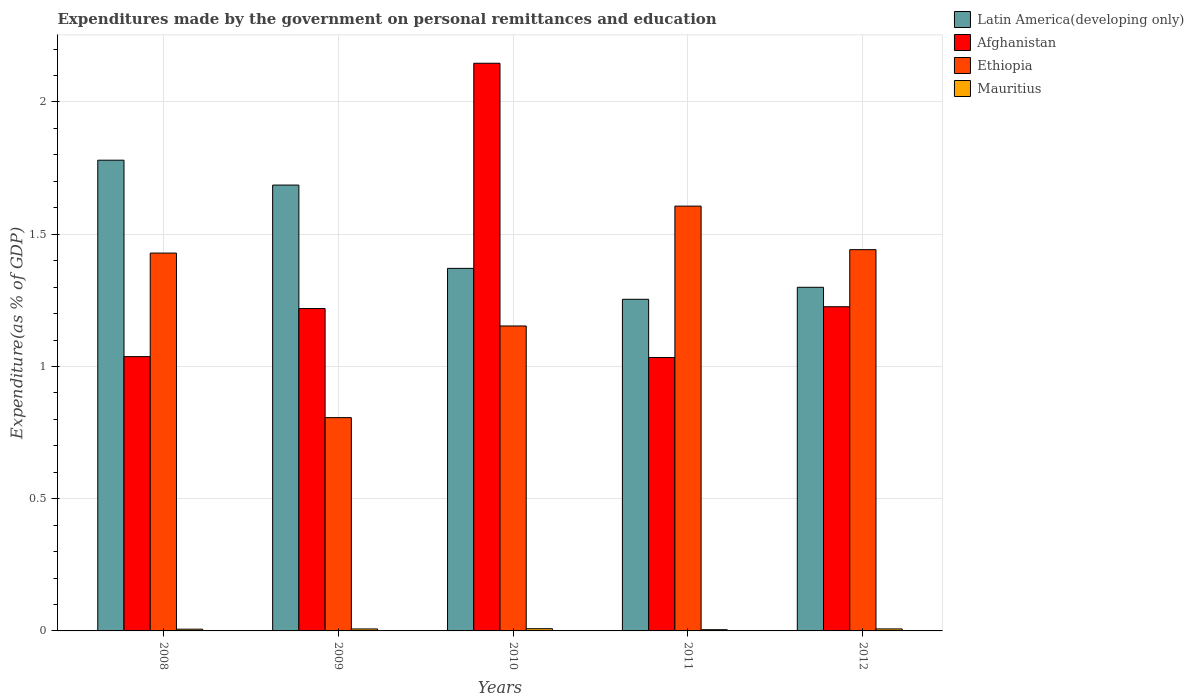What is the expenditures made by the government on personal remittances and education in Mauritius in 2009?
Provide a succinct answer. 0.01. Across all years, what is the maximum expenditures made by the government on personal remittances and education in Latin America(developing only)?
Your answer should be very brief. 1.78. Across all years, what is the minimum expenditures made by the government on personal remittances and education in Mauritius?
Offer a terse response. 0. In which year was the expenditures made by the government on personal remittances and education in Latin America(developing only) minimum?
Offer a terse response. 2011. What is the total expenditures made by the government on personal remittances and education in Latin America(developing only) in the graph?
Provide a short and direct response. 7.39. What is the difference between the expenditures made by the government on personal remittances and education in Ethiopia in 2009 and that in 2012?
Make the answer very short. -0.64. What is the difference between the expenditures made by the government on personal remittances and education in Mauritius in 2011 and the expenditures made by the government on personal remittances and education in Latin America(developing only) in 2010?
Make the answer very short. -1.37. What is the average expenditures made by the government on personal remittances and education in Ethiopia per year?
Provide a succinct answer. 1.29. In the year 2012, what is the difference between the expenditures made by the government on personal remittances and education in Ethiopia and expenditures made by the government on personal remittances and education in Latin America(developing only)?
Make the answer very short. 0.14. What is the ratio of the expenditures made by the government on personal remittances and education in Latin America(developing only) in 2008 to that in 2012?
Your answer should be compact. 1.37. Is the difference between the expenditures made by the government on personal remittances and education in Ethiopia in 2010 and 2012 greater than the difference between the expenditures made by the government on personal remittances and education in Latin America(developing only) in 2010 and 2012?
Your response must be concise. No. What is the difference between the highest and the second highest expenditures made by the government on personal remittances and education in Mauritius?
Make the answer very short. 0. What is the difference between the highest and the lowest expenditures made by the government on personal remittances and education in Latin America(developing only)?
Ensure brevity in your answer.  0.53. In how many years, is the expenditures made by the government on personal remittances and education in Afghanistan greater than the average expenditures made by the government on personal remittances and education in Afghanistan taken over all years?
Provide a short and direct response. 1. Is the sum of the expenditures made by the government on personal remittances and education in Afghanistan in 2010 and 2012 greater than the maximum expenditures made by the government on personal remittances and education in Latin America(developing only) across all years?
Give a very brief answer. Yes. What does the 3rd bar from the left in 2011 represents?
Ensure brevity in your answer.  Ethiopia. What does the 1st bar from the right in 2012 represents?
Offer a terse response. Mauritius. Is it the case that in every year, the sum of the expenditures made by the government on personal remittances and education in Latin America(developing only) and expenditures made by the government on personal remittances and education in Mauritius is greater than the expenditures made by the government on personal remittances and education in Ethiopia?
Give a very brief answer. No. Does the graph contain grids?
Provide a short and direct response. Yes. Where does the legend appear in the graph?
Offer a terse response. Top right. What is the title of the graph?
Provide a succinct answer. Expenditures made by the government on personal remittances and education. Does "Japan" appear as one of the legend labels in the graph?
Your answer should be compact. No. What is the label or title of the X-axis?
Your response must be concise. Years. What is the label or title of the Y-axis?
Keep it short and to the point. Expenditure(as % of GDP). What is the Expenditure(as % of GDP) of Latin America(developing only) in 2008?
Give a very brief answer. 1.78. What is the Expenditure(as % of GDP) of Afghanistan in 2008?
Offer a very short reply. 1.04. What is the Expenditure(as % of GDP) in Ethiopia in 2008?
Provide a short and direct response. 1.43. What is the Expenditure(as % of GDP) in Mauritius in 2008?
Make the answer very short. 0.01. What is the Expenditure(as % of GDP) in Latin America(developing only) in 2009?
Offer a very short reply. 1.69. What is the Expenditure(as % of GDP) of Afghanistan in 2009?
Keep it short and to the point. 1.22. What is the Expenditure(as % of GDP) of Ethiopia in 2009?
Offer a terse response. 0.81. What is the Expenditure(as % of GDP) in Mauritius in 2009?
Offer a terse response. 0.01. What is the Expenditure(as % of GDP) of Latin America(developing only) in 2010?
Ensure brevity in your answer.  1.37. What is the Expenditure(as % of GDP) of Afghanistan in 2010?
Offer a terse response. 2.15. What is the Expenditure(as % of GDP) in Ethiopia in 2010?
Your response must be concise. 1.15. What is the Expenditure(as % of GDP) of Mauritius in 2010?
Your response must be concise. 0.01. What is the Expenditure(as % of GDP) in Latin America(developing only) in 2011?
Offer a terse response. 1.25. What is the Expenditure(as % of GDP) in Afghanistan in 2011?
Offer a terse response. 1.03. What is the Expenditure(as % of GDP) of Ethiopia in 2011?
Give a very brief answer. 1.61. What is the Expenditure(as % of GDP) of Mauritius in 2011?
Ensure brevity in your answer.  0. What is the Expenditure(as % of GDP) in Latin America(developing only) in 2012?
Offer a terse response. 1.3. What is the Expenditure(as % of GDP) of Afghanistan in 2012?
Your response must be concise. 1.23. What is the Expenditure(as % of GDP) in Ethiopia in 2012?
Your response must be concise. 1.44. What is the Expenditure(as % of GDP) of Mauritius in 2012?
Offer a very short reply. 0.01. Across all years, what is the maximum Expenditure(as % of GDP) of Latin America(developing only)?
Provide a succinct answer. 1.78. Across all years, what is the maximum Expenditure(as % of GDP) of Afghanistan?
Keep it short and to the point. 2.15. Across all years, what is the maximum Expenditure(as % of GDP) of Ethiopia?
Offer a very short reply. 1.61. Across all years, what is the maximum Expenditure(as % of GDP) of Mauritius?
Provide a succinct answer. 0.01. Across all years, what is the minimum Expenditure(as % of GDP) in Latin America(developing only)?
Provide a succinct answer. 1.25. Across all years, what is the minimum Expenditure(as % of GDP) in Afghanistan?
Give a very brief answer. 1.03. Across all years, what is the minimum Expenditure(as % of GDP) of Ethiopia?
Provide a short and direct response. 0.81. Across all years, what is the minimum Expenditure(as % of GDP) in Mauritius?
Ensure brevity in your answer.  0. What is the total Expenditure(as % of GDP) in Latin America(developing only) in the graph?
Your answer should be very brief. 7.39. What is the total Expenditure(as % of GDP) of Afghanistan in the graph?
Give a very brief answer. 6.66. What is the total Expenditure(as % of GDP) in Ethiopia in the graph?
Your response must be concise. 6.44. What is the total Expenditure(as % of GDP) of Mauritius in the graph?
Your answer should be very brief. 0.03. What is the difference between the Expenditure(as % of GDP) of Latin America(developing only) in 2008 and that in 2009?
Make the answer very short. 0.09. What is the difference between the Expenditure(as % of GDP) in Afghanistan in 2008 and that in 2009?
Your response must be concise. -0.18. What is the difference between the Expenditure(as % of GDP) of Ethiopia in 2008 and that in 2009?
Offer a very short reply. 0.62. What is the difference between the Expenditure(as % of GDP) of Mauritius in 2008 and that in 2009?
Provide a short and direct response. -0. What is the difference between the Expenditure(as % of GDP) of Latin America(developing only) in 2008 and that in 2010?
Offer a very short reply. 0.41. What is the difference between the Expenditure(as % of GDP) of Afghanistan in 2008 and that in 2010?
Provide a succinct answer. -1.11. What is the difference between the Expenditure(as % of GDP) in Ethiopia in 2008 and that in 2010?
Your answer should be very brief. 0.28. What is the difference between the Expenditure(as % of GDP) in Mauritius in 2008 and that in 2010?
Your answer should be compact. -0. What is the difference between the Expenditure(as % of GDP) in Latin America(developing only) in 2008 and that in 2011?
Make the answer very short. 0.53. What is the difference between the Expenditure(as % of GDP) of Afghanistan in 2008 and that in 2011?
Provide a short and direct response. 0. What is the difference between the Expenditure(as % of GDP) in Ethiopia in 2008 and that in 2011?
Keep it short and to the point. -0.18. What is the difference between the Expenditure(as % of GDP) of Mauritius in 2008 and that in 2011?
Provide a short and direct response. 0. What is the difference between the Expenditure(as % of GDP) in Latin America(developing only) in 2008 and that in 2012?
Offer a terse response. 0.48. What is the difference between the Expenditure(as % of GDP) in Afghanistan in 2008 and that in 2012?
Your answer should be very brief. -0.19. What is the difference between the Expenditure(as % of GDP) of Ethiopia in 2008 and that in 2012?
Provide a short and direct response. -0.01. What is the difference between the Expenditure(as % of GDP) in Mauritius in 2008 and that in 2012?
Ensure brevity in your answer.  -0. What is the difference between the Expenditure(as % of GDP) in Latin America(developing only) in 2009 and that in 2010?
Offer a terse response. 0.32. What is the difference between the Expenditure(as % of GDP) of Afghanistan in 2009 and that in 2010?
Provide a succinct answer. -0.93. What is the difference between the Expenditure(as % of GDP) of Ethiopia in 2009 and that in 2010?
Ensure brevity in your answer.  -0.35. What is the difference between the Expenditure(as % of GDP) of Mauritius in 2009 and that in 2010?
Keep it short and to the point. -0. What is the difference between the Expenditure(as % of GDP) of Latin America(developing only) in 2009 and that in 2011?
Ensure brevity in your answer.  0.43. What is the difference between the Expenditure(as % of GDP) of Afghanistan in 2009 and that in 2011?
Keep it short and to the point. 0.19. What is the difference between the Expenditure(as % of GDP) in Ethiopia in 2009 and that in 2011?
Ensure brevity in your answer.  -0.8. What is the difference between the Expenditure(as % of GDP) in Mauritius in 2009 and that in 2011?
Your answer should be compact. 0. What is the difference between the Expenditure(as % of GDP) of Latin America(developing only) in 2009 and that in 2012?
Provide a succinct answer. 0.39. What is the difference between the Expenditure(as % of GDP) in Afghanistan in 2009 and that in 2012?
Ensure brevity in your answer.  -0.01. What is the difference between the Expenditure(as % of GDP) in Ethiopia in 2009 and that in 2012?
Keep it short and to the point. -0.64. What is the difference between the Expenditure(as % of GDP) of Mauritius in 2009 and that in 2012?
Ensure brevity in your answer.  -0. What is the difference between the Expenditure(as % of GDP) in Latin America(developing only) in 2010 and that in 2011?
Offer a terse response. 0.12. What is the difference between the Expenditure(as % of GDP) in Afghanistan in 2010 and that in 2011?
Make the answer very short. 1.11. What is the difference between the Expenditure(as % of GDP) in Ethiopia in 2010 and that in 2011?
Your response must be concise. -0.45. What is the difference between the Expenditure(as % of GDP) of Mauritius in 2010 and that in 2011?
Provide a short and direct response. 0. What is the difference between the Expenditure(as % of GDP) in Latin America(developing only) in 2010 and that in 2012?
Your answer should be very brief. 0.07. What is the difference between the Expenditure(as % of GDP) of Afghanistan in 2010 and that in 2012?
Provide a succinct answer. 0.92. What is the difference between the Expenditure(as % of GDP) of Ethiopia in 2010 and that in 2012?
Make the answer very short. -0.29. What is the difference between the Expenditure(as % of GDP) in Mauritius in 2010 and that in 2012?
Provide a short and direct response. 0. What is the difference between the Expenditure(as % of GDP) of Latin America(developing only) in 2011 and that in 2012?
Ensure brevity in your answer.  -0.05. What is the difference between the Expenditure(as % of GDP) in Afghanistan in 2011 and that in 2012?
Keep it short and to the point. -0.19. What is the difference between the Expenditure(as % of GDP) of Ethiopia in 2011 and that in 2012?
Keep it short and to the point. 0.16. What is the difference between the Expenditure(as % of GDP) in Mauritius in 2011 and that in 2012?
Provide a short and direct response. -0. What is the difference between the Expenditure(as % of GDP) in Latin America(developing only) in 2008 and the Expenditure(as % of GDP) in Afghanistan in 2009?
Make the answer very short. 0.56. What is the difference between the Expenditure(as % of GDP) in Latin America(developing only) in 2008 and the Expenditure(as % of GDP) in Ethiopia in 2009?
Offer a very short reply. 0.97. What is the difference between the Expenditure(as % of GDP) in Latin America(developing only) in 2008 and the Expenditure(as % of GDP) in Mauritius in 2009?
Your response must be concise. 1.77. What is the difference between the Expenditure(as % of GDP) of Afghanistan in 2008 and the Expenditure(as % of GDP) of Ethiopia in 2009?
Give a very brief answer. 0.23. What is the difference between the Expenditure(as % of GDP) in Afghanistan in 2008 and the Expenditure(as % of GDP) in Mauritius in 2009?
Ensure brevity in your answer.  1.03. What is the difference between the Expenditure(as % of GDP) in Ethiopia in 2008 and the Expenditure(as % of GDP) in Mauritius in 2009?
Your answer should be compact. 1.42. What is the difference between the Expenditure(as % of GDP) in Latin America(developing only) in 2008 and the Expenditure(as % of GDP) in Afghanistan in 2010?
Offer a very short reply. -0.37. What is the difference between the Expenditure(as % of GDP) in Latin America(developing only) in 2008 and the Expenditure(as % of GDP) in Ethiopia in 2010?
Offer a very short reply. 0.63. What is the difference between the Expenditure(as % of GDP) of Latin America(developing only) in 2008 and the Expenditure(as % of GDP) of Mauritius in 2010?
Your response must be concise. 1.77. What is the difference between the Expenditure(as % of GDP) of Afghanistan in 2008 and the Expenditure(as % of GDP) of Ethiopia in 2010?
Your response must be concise. -0.12. What is the difference between the Expenditure(as % of GDP) in Afghanistan in 2008 and the Expenditure(as % of GDP) in Mauritius in 2010?
Give a very brief answer. 1.03. What is the difference between the Expenditure(as % of GDP) in Ethiopia in 2008 and the Expenditure(as % of GDP) in Mauritius in 2010?
Offer a terse response. 1.42. What is the difference between the Expenditure(as % of GDP) in Latin America(developing only) in 2008 and the Expenditure(as % of GDP) in Afghanistan in 2011?
Offer a very short reply. 0.75. What is the difference between the Expenditure(as % of GDP) in Latin America(developing only) in 2008 and the Expenditure(as % of GDP) in Ethiopia in 2011?
Offer a terse response. 0.17. What is the difference between the Expenditure(as % of GDP) in Latin America(developing only) in 2008 and the Expenditure(as % of GDP) in Mauritius in 2011?
Your answer should be compact. 1.78. What is the difference between the Expenditure(as % of GDP) of Afghanistan in 2008 and the Expenditure(as % of GDP) of Ethiopia in 2011?
Keep it short and to the point. -0.57. What is the difference between the Expenditure(as % of GDP) in Afghanistan in 2008 and the Expenditure(as % of GDP) in Mauritius in 2011?
Offer a terse response. 1.03. What is the difference between the Expenditure(as % of GDP) in Ethiopia in 2008 and the Expenditure(as % of GDP) in Mauritius in 2011?
Make the answer very short. 1.42. What is the difference between the Expenditure(as % of GDP) in Latin America(developing only) in 2008 and the Expenditure(as % of GDP) in Afghanistan in 2012?
Your response must be concise. 0.55. What is the difference between the Expenditure(as % of GDP) of Latin America(developing only) in 2008 and the Expenditure(as % of GDP) of Ethiopia in 2012?
Give a very brief answer. 0.34. What is the difference between the Expenditure(as % of GDP) in Latin America(developing only) in 2008 and the Expenditure(as % of GDP) in Mauritius in 2012?
Ensure brevity in your answer.  1.77. What is the difference between the Expenditure(as % of GDP) of Afghanistan in 2008 and the Expenditure(as % of GDP) of Ethiopia in 2012?
Offer a terse response. -0.4. What is the difference between the Expenditure(as % of GDP) of Afghanistan in 2008 and the Expenditure(as % of GDP) of Mauritius in 2012?
Ensure brevity in your answer.  1.03. What is the difference between the Expenditure(as % of GDP) in Ethiopia in 2008 and the Expenditure(as % of GDP) in Mauritius in 2012?
Ensure brevity in your answer.  1.42. What is the difference between the Expenditure(as % of GDP) of Latin America(developing only) in 2009 and the Expenditure(as % of GDP) of Afghanistan in 2010?
Your response must be concise. -0.46. What is the difference between the Expenditure(as % of GDP) in Latin America(developing only) in 2009 and the Expenditure(as % of GDP) in Ethiopia in 2010?
Provide a succinct answer. 0.53. What is the difference between the Expenditure(as % of GDP) of Latin America(developing only) in 2009 and the Expenditure(as % of GDP) of Mauritius in 2010?
Your response must be concise. 1.68. What is the difference between the Expenditure(as % of GDP) in Afghanistan in 2009 and the Expenditure(as % of GDP) in Ethiopia in 2010?
Provide a succinct answer. 0.07. What is the difference between the Expenditure(as % of GDP) of Afghanistan in 2009 and the Expenditure(as % of GDP) of Mauritius in 2010?
Make the answer very short. 1.21. What is the difference between the Expenditure(as % of GDP) in Ethiopia in 2009 and the Expenditure(as % of GDP) in Mauritius in 2010?
Provide a succinct answer. 0.8. What is the difference between the Expenditure(as % of GDP) of Latin America(developing only) in 2009 and the Expenditure(as % of GDP) of Afghanistan in 2011?
Offer a terse response. 0.65. What is the difference between the Expenditure(as % of GDP) in Latin America(developing only) in 2009 and the Expenditure(as % of GDP) in Ethiopia in 2011?
Your response must be concise. 0.08. What is the difference between the Expenditure(as % of GDP) in Latin America(developing only) in 2009 and the Expenditure(as % of GDP) in Mauritius in 2011?
Provide a short and direct response. 1.68. What is the difference between the Expenditure(as % of GDP) of Afghanistan in 2009 and the Expenditure(as % of GDP) of Ethiopia in 2011?
Keep it short and to the point. -0.39. What is the difference between the Expenditure(as % of GDP) of Afghanistan in 2009 and the Expenditure(as % of GDP) of Mauritius in 2011?
Your answer should be compact. 1.21. What is the difference between the Expenditure(as % of GDP) in Ethiopia in 2009 and the Expenditure(as % of GDP) in Mauritius in 2011?
Make the answer very short. 0.8. What is the difference between the Expenditure(as % of GDP) of Latin America(developing only) in 2009 and the Expenditure(as % of GDP) of Afghanistan in 2012?
Your response must be concise. 0.46. What is the difference between the Expenditure(as % of GDP) in Latin America(developing only) in 2009 and the Expenditure(as % of GDP) in Ethiopia in 2012?
Your response must be concise. 0.24. What is the difference between the Expenditure(as % of GDP) in Latin America(developing only) in 2009 and the Expenditure(as % of GDP) in Mauritius in 2012?
Make the answer very short. 1.68. What is the difference between the Expenditure(as % of GDP) in Afghanistan in 2009 and the Expenditure(as % of GDP) in Ethiopia in 2012?
Keep it short and to the point. -0.22. What is the difference between the Expenditure(as % of GDP) in Afghanistan in 2009 and the Expenditure(as % of GDP) in Mauritius in 2012?
Give a very brief answer. 1.21. What is the difference between the Expenditure(as % of GDP) of Ethiopia in 2009 and the Expenditure(as % of GDP) of Mauritius in 2012?
Make the answer very short. 0.8. What is the difference between the Expenditure(as % of GDP) of Latin America(developing only) in 2010 and the Expenditure(as % of GDP) of Afghanistan in 2011?
Make the answer very short. 0.34. What is the difference between the Expenditure(as % of GDP) of Latin America(developing only) in 2010 and the Expenditure(as % of GDP) of Ethiopia in 2011?
Your answer should be very brief. -0.24. What is the difference between the Expenditure(as % of GDP) of Latin America(developing only) in 2010 and the Expenditure(as % of GDP) of Mauritius in 2011?
Offer a terse response. 1.37. What is the difference between the Expenditure(as % of GDP) in Afghanistan in 2010 and the Expenditure(as % of GDP) in Ethiopia in 2011?
Offer a terse response. 0.54. What is the difference between the Expenditure(as % of GDP) in Afghanistan in 2010 and the Expenditure(as % of GDP) in Mauritius in 2011?
Make the answer very short. 2.14. What is the difference between the Expenditure(as % of GDP) of Ethiopia in 2010 and the Expenditure(as % of GDP) of Mauritius in 2011?
Provide a succinct answer. 1.15. What is the difference between the Expenditure(as % of GDP) in Latin America(developing only) in 2010 and the Expenditure(as % of GDP) in Afghanistan in 2012?
Provide a short and direct response. 0.14. What is the difference between the Expenditure(as % of GDP) in Latin America(developing only) in 2010 and the Expenditure(as % of GDP) in Ethiopia in 2012?
Give a very brief answer. -0.07. What is the difference between the Expenditure(as % of GDP) in Latin America(developing only) in 2010 and the Expenditure(as % of GDP) in Mauritius in 2012?
Your answer should be compact. 1.36. What is the difference between the Expenditure(as % of GDP) of Afghanistan in 2010 and the Expenditure(as % of GDP) of Ethiopia in 2012?
Ensure brevity in your answer.  0.7. What is the difference between the Expenditure(as % of GDP) in Afghanistan in 2010 and the Expenditure(as % of GDP) in Mauritius in 2012?
Offer a terse response. 2.14. What is the difference between the Expenditure(as % of GDP) in Ethiopia in 2010 and the Expenditure(as % of GDP) in Mauritius in 2012?
Ensure brevity in your answer.  1.15. What is the difference between the Expenditure(as % of GDP) in Latin America(developing only) in 2011 and the Expenditure(as % of GDP) in Afghanistan in 2012?
Make the answer very short. 0.03. What is the difference between the Expenditure(as % of GDP) in Latin America(developing only) in 2011 and the Expenditure(as % of GDP) in Ethiopia in 2012?
Your response must be concise. -0.19. What is the difference between the Expenditure(as % of GDP) of Latin America(developing only) in 2011 and the Expenditure(as % of GDP) of Mauritius in 2012?
Your response must be concise. 1.25. What is the difference between the Expenditure(as % of GDP) of Afghanistan in 2011 and the Expenditure(as % of GDP) of Ethiopia in 2012?
Your answer should be very brief. -0.41. What is the difference between the Expenditure(as % of GDP) of Afghanistan in 2011 and the Expenditure(as % of GDP) of Mauritius in 2012?
Keep it short and to the point. 1.03. What is the difference between the Expenditure(as % of GDP) of Ethiopia in 2011 and the Expenditure(as % of GDP) of Mauritius in 2012?
Offer a terse response. 1.6. What is the average Expenditure(as % of GDP) in Latin America(developing only) per year?
Make the answer very short. 1.48. What is the average Expenditure(as % of GDP) in Afghanistan per year?
Provide a short and direct response. 1.33. What is the average Expenditure(as % of GDP) in Ethiopia per year?
Offer a very short reply. 1.29. What is the average Expenditure(as % of GDP) of Mauritius per year?
Keep it short and to the point. 0.01. In the year 2008, what is the difference between the Expenditure(as % of GDP) of Latin America(developing only) and Expenditure(as % of GDP) of Afghanistan?
Keep it short and to the point. 0.74. In the year 2008, what is the difference between the Expenditure(as % of GDP) in Latin America(developing only) and Expenditure(as % of GDP) in Ethiopia?
Ensure brevity in your answer.  0.35. In the year 2008, what is the difference between the Expenditure(as % of GDP) of Latin America(developing only) and Expenditure(as % of GDP) of Mauritius?
Make the answer very short. 1.77. In the year 2008, what is the difference between the Expenditure(as % of GDP) in Afghanistan and Expenditure(as % of GDP) in Ethiopia?
Ensure brevity in your answer.  -0.39. In the year 2008, what is the difference between the Expenditure(as % of GDP) of Afghanistan and Expenditure(as % of GDP) of Mauritius?
Give a very brief answer. 1.03. In the year 2008, what is the difference between the Expenditure(as % of GDP) in Ethiopia and Expenditure(as % of GDP) in Mauritius?
Your answer should be compact. 1.42. In the year 2009, what is the difference between the Expenditure(as % of GDP) of Latin America(developing only) and Expenditure(as % of GDP) of Afghanistan?
Your answer should be very brief. 0.47. In the year 2009, what is the difference between the Expenditure(as % of GDP) in Latin America(developing only) and Expenditure(as % of GDP) in Ethiopia?
Give a very brief answer. 0.88. In the year 2009, what is the difference between the Expenditure(as % of GDP) of Latin America(developing only) and Expenditure(as % of GDP) of Mauritius?
Your answer should be compact. 1.68. In the year 2009, what is the difference between the Expenditure(as % of GDP) in Afghanistan and Expenditure(as % of GDP) in Ethiopia?
Provide a succinct answer. 0.41. In the year 2009, what is the difference between the Expenditure(as % of GDP) of Afghanistan and Expenditure(as % of GDP) of Mauritius?
Ensure brevity in your answer.  1.21. In the year 2009, what is the difference between the Expenditure(as % of GDP) of Ethiopia and Expenditure(as % of GDP) of Mauritius?
Provide a short and direct response. 0.8. In the year 2010, what is the difference between the Expenditure(as % of GDP) in Latin America(developing only) and Expenditure(as % of GDP) in Afghanistan?
Your answer should be very brief. -0.78. In the year 2010, what is the difference between the Expenditure(as % of GDP) of Latin America(developing only) and Expenditure(as % of GDP) of Ethiopia?
Keep it short and to the point. 0.22. In the year 2010, what is the difference between the Expenditure(as % of GDP) in Latin America(developing only) and Expenditure(as % of GDP) in Mauritius?
Offer a terse response. 1.36. In the year 2010, what is the difference between the Expenditure(as % of GDP) in Afghanistan and Expenditure(as % of GDP) in Ethiopia?
Your response must be concise. 0.99. In the year 2010, what is the difference between the Expenditure(as % of GDP) of Afghanistan and Expenditure(as % of GDP) of Mauritius?
Ensure brevity in your answer.  2.14. In the year 2010, what is the difference between the Expenditure(as % of GDP) of Ethiopia and Expenditure(as % of GDP) of Mauritius?
Keep it short and to the point. 1.14. In the year 2011, what is the difference between the Expenditure(as % of GDP) of Latin America(developing only) and Expenditure(as % of GDP) of Afghanistan?
Provide a succinct answer. 0.22. In the year 2011, what is the difference between the Expenditure(as % of GDP) of Latin America(developing only) and Expenditure(as % of GDP) of Ethiopia?
Offer a very short reply. -0.35. In the year 2011, what is the difference between the Expenditure(as % of GDP) of Latin America(developing only) and Expenditure(as % of GDP) of Mauritius?
Provide a succinct answer. 1.25. In the year 2011, what is the difference between the Expenditure(as % of GDP) in Afghanistan and Expenditure(as % of GDP) in Ethiopia?
Your response must be concise. -0.57. In the year 2011, what is the difference between the Expenditure(as % of GDP) of Afghanistan and Expenditure(as % of GDP) of Mauritius?
Provide a short and direct response. 1.03. In the year 2011, what is the difference between the Expenditure(as % of GDP) of Ethiopia and Expenditure(as % of GDP) of Mauritius?
Ensure brevity in your answer.  1.6. In the year 2012, what is the difference between the Expenditure(as % of GDP) in Latin America(developing only) and Expenditure(as % of GDP) in Afghanistan?
Provide a succinct answer. 0.07. In the year 2012, what is the difference between the Expenditure(as % of GDP) in Latin America(developing only) and Expenditure(as % of GDP) in Ethiopia?
Your response must be concise. -0.14. In the year 2012, what is the difference between the Expenditure(as % of GDP) in Latin America(developing only) and Expenditure(as % of GDP) in Mauritius?
Provide a short and direct response. 1.29. In the year 2012, what is the difference between the Expenditure(as % of GDP) in Afghanistan and Expenditure(as % of GDP) in Ethiopia?
Ensure brevity in your answer.  -0.22. In the year 2012, what is the difference between the Expenditure(as % of GDP) of Afghanistan and Expenditure(as % of GDP) of Mauritius?
Make the answer very short. 1.22. In the year 2012, what is the difference between the Expenditure(as % of GDP) of Ethiopia and Expenditure(as % of GDP) of Mauritius?
Give a very brief answer. 1.43. What is the ratio of the Expenditure(as % of GDP) in Latin America(developing only) in 2008 to that in 2009?
Provide a short and direct response. 1.06. What is the ratio of the Expenditure(as % of GDP) in Afghanistan in 2008 to that in 2009?
Give a very brief answer. 0.85. What is the ratio of the Expenditure(as % of GDP) of Ethiopia in 2008 to that in 2009?
Your answer should be very brief. 1.77. What is the ratio of the Expenditure(as % of GDP) in Mauritius in 2008 to that in 2009?
Offer a terse response. 0.88. What is the ratio of the Expenditure(as % of GDP) of Latin America(developing only) in 2008 to that in 2010?
Make the answer very short. 1.3. What is the ratio of the Expenditure(as % of GDP) in Afghanistan in 2008 to that in 2010?
Offer a very short reply. 0.48. What is the ratio of the Expenditure(as % of GDP) in Ethiopia in 2008 to that in 2010?
Give a very brief answer. 1.24. What is the ratio of the Expenditure(as % of GDP) of Mauritius in 2008 to that in 2010?
Your answer should be very brief. 0.78. What is the ratio of the Expenditure(as % of GDP) in Latin America(developing only) in 2008 to that in 2011?
Ensure brevity in your answer.  1.42. What is the ratio of the Expenditure(as % of GDP) of Ethiopia in 2008 to that in 2011?
Your answer should be compact. 0.89. What is the ratio of the Expenditure(as % of GDP) in Mauritius in 2008 to that in 2011?
Your answer should be very brief. 1.43. What is the ratio of the Expenditure(as % of GDP) in Latin America(developing only) in 2008 to that in 2012?
Your answer should be compact. 1.37. What is the ratio of the Expenditure(as % of GDP) of Afghanistan in 2008 to that in 2012?
Offer a terse response. 0.85. What is the ratio of the Expenditure(as % of GDP) in Mauritius in 2008 to that in 2012?
Provide a short and direct response. 0.87. What is the ratio of the Expenditure(as % of GDP) of Latin America(developing only) in 2009 to that in 2010?
Provide a short and direct response. 1.23. What is the ratio of the Expenditure(as % of GDP) in Afghanistan in 2009 to that in 2010?
Give a very brief answer. 0.57. What is the ratio of the Expenditure(as % of GDP) of Ethiopia in 2009 to that in 2010?
Provide a succinct answer. 0.7. What is the ratio of the Expenditure(as % of GDP) of Mauritius in 2009 to that in 2010?
Provide a short and direct response. 0.89. What is the ratio of the Expenditure(as % of GDP) of Latin America(developing only) in 2009 to that in 2011?
Keep it short and to the point. 1.34. What is the ratio of the Expenditure(as % of GDP) of Afghanistan in 2009 to that in 2011?
Make the answer very short. 1.18. What is the ratio of the Expenditure(as % of GDP) in Ethiopia in 2009 to that in 2011?
Offer a very short reply. 0.5. What is the ratio of the Expenditure(as % of GDP) of Mauritius in 2009 to that in 2011?
Provide a succinct answer. 1.62. What is the ratio of the Expenditure(as % of GDP) of Latin America(developing only) in 2009 to that in 2012?
Provide a short and direct response. 1.3. What is the ratio of the Expenditure(as % of GDP) of Afghanistan in 2009 to that in 2012?
Ensure brevity in your answer.  0.99. What is the ratio of the Expenditure(as % of GDP) of Ethiopia in 2009 to that in 2012?
Offer a very short reply. 0.56. What is the ratio of the Expenditure(as % of GDP) in Mauritius in 2009 to that in 2012?
Make the answer very short. 0.99. What is the ratio of the Expenditure(as % of GDP) of Latin America(developing only) in 2010 to that in 2011?
Provide a succinct answer. 1.09. What is the ratio of the Expenditure(as % of GDP) in Afghanistan in 2010 to that in 2011?
Your answer should be compact. 2.08. What is the ratio of the Expenditure(as % of GDP) of Ethiopia in 2010 to that in 2011?
Keep it short and to the point. 0.72. What is the ratio of the Expenditure(as % of GDP) in Mauritius in 2010 to that in 2011?
Offer a terse response. 1.82. What is the ratio of the Expenditure(as % of GDP) in Latin America(developing only) in 2010 to that in 2012?
Provide a short and direct response. 1.05. What is the ratio of the Expenditure(as % of GDP) of Afghanistan in 2010 to that in 2012?
Make the answer very short. 1.75. What is the ratio of the Expenditure(as % of GDP) of Ethiopia in 2010 to that in 2012?
Offer a terse response. 0.8. What is the ratio of the Expenditure(as % of GDP) of Mauritius in 2010 to that in 2012?
Your answer should be compact. 1.11. What is the ratio of the Expenditure(as % of GDP) of Latin America(developing only) in 2011 to that in 2012?
Your response must be concise. 0.97. What is the ratio of the Expenditure(as % of GDP) in Afghanistan in 2011 to that in 2012?
Offer a very short reply. 0.84. What is the ratio of the Expenditure(as % of GDP) of Ethiopia in 2011 to that in 2012?
Your response must be concise. 1.11. What is the ratio of the Expenditure(as % of GDP) in Mauritius in 2011 to that in 2012?
Provide a short and direct response. 0.61. What is the difference between the highest and the second highest Expenditure(as % of GDP) in Latin America(developing only)?
Your answer should be compact. 0.09. What is the difference between the highest and the second highest Expenditure(as % of GDP) in Afghanistan?
Provide a succinct answer. 0.92. What is the difference between the highest and the second highest Expenditure(as % of GDP) of Ethiopia?
Provide a short and direct response. 0.16. What is the difference between the highest and the second highest Expenditure(as % of GDP) of Mauritius?
Make the answer very short. 0. What is the difference between the highest and the lowest Expenditure(as % of GDP) of Latin America(developing only)?
Give a very brief answer. 0.53. What is the difference between the highest and the lowest Expenditure(as % of GDP) in Afghanistan?
Your response must be concise. 1.11. What is the difference between the highest and the lowest Expenditure(as % of GDP) in Ethiopia?
Offer a terse response. 0.8. What is the difference between the highest and the lowest Expenditure(as % of GDP) in Mauritius?
Your answer should be very brief. 0. 